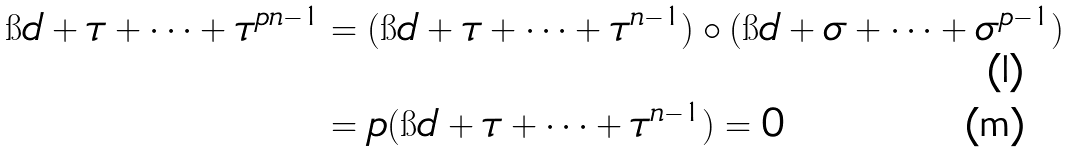<formula> <loc_0><loc_0><loc_500><loc_500>\i d + \tau + \dots + \tau ^ { p n - 1 } & = ( \i d + \tau + \dots + \tau ^ { n - 1 } ) \circ ( \i d + \sigma + \dots + \sigma ^ { p - 1 } ) \\ & = p ( \i d + \tau + \dots + \tau ^ { n - 1 } ) = 0</formula> 